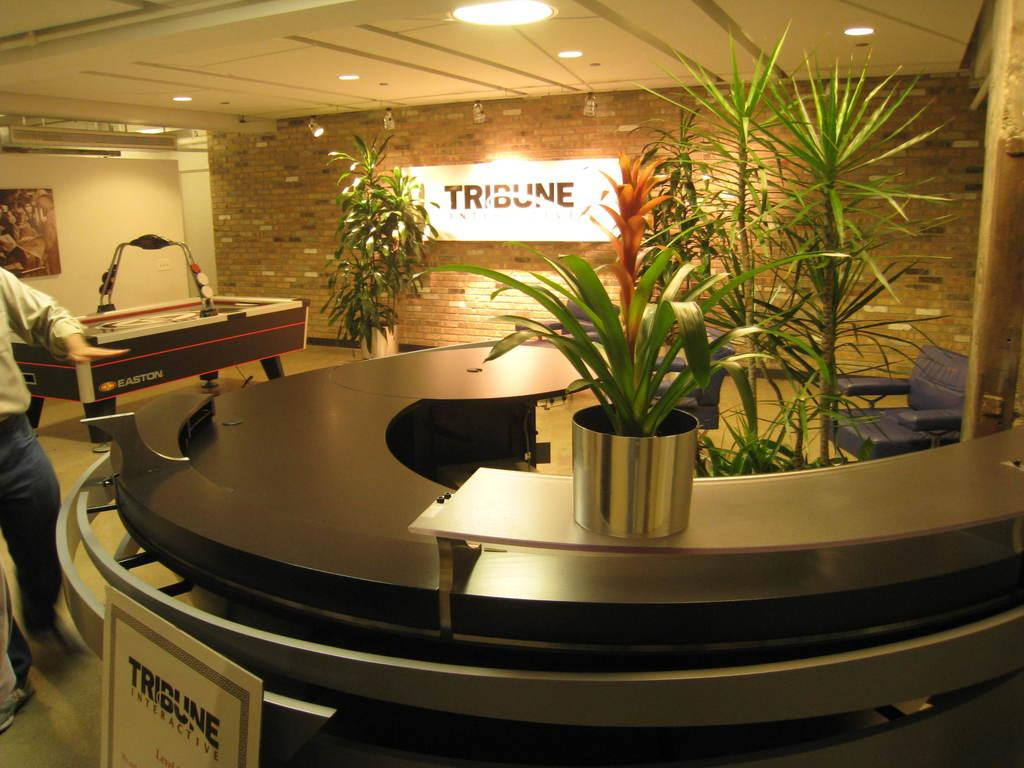What is the man in the image doing? There is a man walking in the image. What can be seen in the background of the image? There are plants visible in the image. What type of furniture is present in the image? There is a chair in the image. What type of lighting is present in the image? There are roof lights in the image. What type of person is being held in the jail in the image? There is no jail present in the image, so it is not possible to answer that question. 